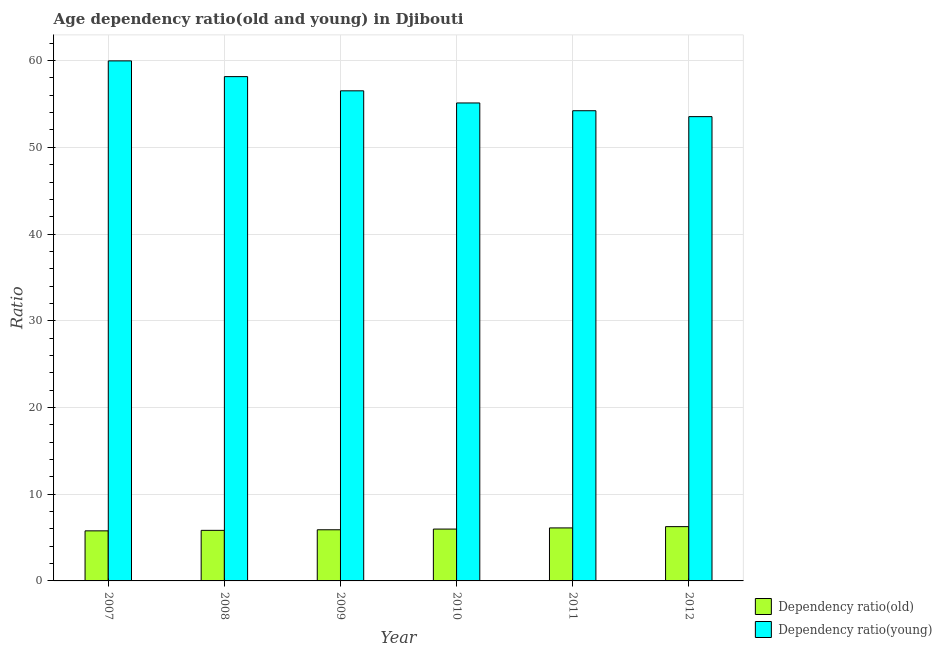How many different coloured bars are there?
Provide a short and direct response. 2. How many bars are there on the 3rd tick from the right?
Your response must be concise. 2. In how many cases, is the number of bars for a given year not equal to the number of legend labels?
Offer a terse response. 0. What is the age dependency ratio(old) in 2007?
Provide a succinct answer. 5.77. Across all years, what is the maximum age dependency ratio(old)?
Offer a terse response. 6.26. Across all years, what is the minimum age dependency ratio(old)?
Your response must be concise. 5.77. What is the total age dependency ratio(old) in the graph?
Your answer should be compact. 35.85. What is the difference between the age dependency ratio(old) in 2007 and that in 2012?
Your answer should be compact. -0.49. What is the difference between the age dependency ratio(young) in 2012 and the age dependency ratio(old) in 2007?
Give a very brief answer. -6.43. What is the average age dependency ratio(young) per year?
Your response must be concise. 56.25. In the year 2011, what is the difference between the age dependency ratio(old) and age dependency ratio(young)?
Offer a very short reply. 0. In how many years, is the age dependency ratio(old) greater than 20?
Ensure brevity in your answer.  0. What is the ratio of the age dependency ratio(young) in 2008 to that in 2010?
Offer a terse response. 1.06. Is the difference between the age dependency ratio(young) in 2010 and 2012 greater than the difference between the age dependency ratio(old) in 2010 and 2012?
Your response must be concise. No. What is the difference between the highest and the second highest age dependency ratio(old)?
Make the answer very short. 0.15. What is the difference between the highest and the lowest age dependency ratio(young)?
Ensure brevity in your answer.  6.43. Is the sum of the age dependency ratio(old) in 2007 and 2010 greater than the maximum age dependency ratio(young) across all years?
Ensure brevity in your answer.  Yes. What does the 1st bar from the left in 2012 represents?
Provide a succinct answer. Dependency ratio(old). What does the 1st bar from the right in 2007 represents?
Offer a very short reply. Dependency ratio(young). How many bars are there?
Keep it short and to the point. 12. How many years are there in the graph?
Ensure brevity in your answer.  6. What is the difference between two consecutive major ticks on the Y-axis?
Offer a very short reply. 10. Are the values on the major ticks of Y-axis written in scientific E-notation?
Give a very brief answer. No. Where does the legend appear in the graph?
Keep it short and to the point. Bottom right. How many legend labels are there?
Ensure brevity in your answer.  2. How are the legend labels stacked?
Your answer should be compact. Vertical. What is the title of the graph?
Your response must be concise. Age dependency ratio(old and young) in Djibouti. What is the label or title of the X-axis?
Ensure brevity in your answer.  Year. What is the label or title of the Y-axis?
Offer a very short reply. Ratio. What is the Ratio in Dependency ratio(old) in 2007?
Offer a very short reply. 5.77. What is the Ratio in Dependency ratio(young) in 2007?
Keep it short and to the point. 59.97. What is the Ratio in Dependency ratio(old) in 2008?
Your answer should be compact. 5.83. What is the Ratio in Dependency ratio(young) in 2008?
Your answer should be compact. 58.15. What is the Ratio in Dependency ratio(old) in 2009?
Offer a terse response. 5.9. What is the Ratio of Dependency ratio(young) in 2009?
Your response must be concise. 56.52. What is the Ratio of Dependency ratio(old) in 2010?
Offer a very short reply. 5.98. What is the Ratio of Dependency ratio(young) in 2010?
Offer a very short reply. 55.12. What is the Ratio of Dependency ratio(old) in 2011?
Offer a very short reply. 6.11. What is the Ratio in Dependency ratio(young) in 2011?
Your response must be concise. 54.22. What is the Ratio in Dependency ratio(old) in 2012?
Offer a terse response. 6.26. What is the Ratio in Dependency ratio(young) in 2012?
Ensure brevity in your answer.  53.54. Across all years, what is the maximum Ratio in Dependency ratio(old)?
Provide a succinct answer. 6.26. Across all years, what is the maximum Ratio of Dependency ratio(young)?
Offer a terse response. 59.97. Across all years, what is the minimum Ratio of Dependency ratio(old)?
Ensure brevity in your answer.  5.77. Across all years, what is the minimum Ratio of Dependency ratio(young)?
Give a very brief answer. 53.54. What is the total Ratio of Dependency ratio(old) in the graph?
Keep it short and to the point. 35.85. What is the total Ratio in Dependency ratio(young) in the graph?
Give a very brief answer. 337.51. What is the difference between the Ratio in Dependency ratio(old) in 2007 and that in 2008?
Keep it short and to the point. -0.06. What is the difference between the Ratio in Dependency ratio(young) in 2007 and that in 2008?
Your answer should be compact. 1.81. What is the difference between the Ratio of Dependency ratio(old) in 2007 and that in 2009?
Your response must be concise. -0.13. What is the difference between the Ratio in Dependency ratio(young) in 2007 and that in 2009?
Keep it short and to the point. 3.45. What is the difference between the Ratio of Dependency ratio(old) in 2007 and that in 2010?
Your response must be concise. -0.21. What is the difference between the Ratio in Dependency ratio(young) in 2007 and that in 2010?
Your answer should be compact. 4.85. What is the difference between the Ratio in Dependency ratio(old) in 2007 and that in 2011?
Your answer should be compact. -0.34. What is the difference between the Ratio in Dependency ratio(young) in 2007 and that in 2011?
Keep it short and to the point. 5.75. What is the difference between the Ratio in Dependency ratio(old) in 2007 and that in 2012?
Give a very brief answer. -0.49. What is the difference between the Ratio of Dependency ratio(young) in 2007 and that in 2012?
Ensure brevity in your answer.  6.43. What is the difference between the Ratio of Dependency ratio(old) in 2008 and that in 2009?
Your answer should be compact. -0.07. What is the difference between the Ratio of Dependency ratio(young) in 2008 and that in 2009?
Your response must be concise. 1.64. What is the difference between the Ratio of Dependency ratio(old) in 2008 and that in 2010?
Provide a short and direct response. -0.15. What is the difference between the Ratio in Dependency ratio(young) in 2008 and that in 2010?
Provide a succinct answer. 3.04. What is the difference between the Ratio in Dependency ratio(old) in 2008 and that in 2011?
Your answer should be compact. -0.28. What is the difference between the Ratio of Dependency ratio(young) in 2008 and that in 2011?
Your answer should be compact. 3.93. What is the difference between the Ratio of Dependency ratio(old) in 2008 and that in 2012?
Offer a very short reply. -0.43. What is the difference between the Ratio of Dependency ratio(young) in 2008 and that in 2012?
Provide a succinct answer. 4.62. What is the difference between the Ratio of Dependency ratio(old) in 2009 and that in 2010?
Your answer should be compact. -0.08. What is the difference between the Ratio of Dependency ratio(young) in 2009 and that in 2010?
Provide a succinct answer. 1.4. What is the difference between the Ratio in Dependency ratio(old) in 2009 and that in 2011?
Your response must be concise. -0.21. What is the difference between the Ratio in Dependency ratio(young) in 2009 and that in 2011?
Give a very brief answer. 2.3. What is the difference between the Ratio in Dependency ratio(old) in 2009 and that in 2012?
Provide a short and direct response. -0.36. What is the difference between the Ratio in Dependency ratio(young) in 2009 and that in 2012?
Your response must be concise. 2.98. What is the difference between the Ratio of Dependency ratio(old) in 2010 and that in 2011?
Your answer should be very brief. -0.13. What is the difference between the Ratio of Dependency ratio(young) in 2010 and that in 2011?
Offer a very short reply. 0.9. What is the difference between the Ratio in Dependency ratio(old) in 2010 and that in 2012?
Offer a terse response. -0.28. What is the difference between the Ratio of Dependency ratio(young) in 2010 and that in 2012?
Keep it short and to the point. 1.58. What is the difference between the Ratio of Dependency ratio(old) in 2011 and that in 2012?
Ensure brevity in your answer.  -0.15. What is the difference between the Ratio of Dependency ratio(young) in 2011 and that in 2012?
Your response must be concise. 0.68. What is the difference between the Ratio of Dependency ratio(old) in 2007 and the Ratio of Dependency ratio(young) in 2008?
Your response must be concise. -52.38. What is the difference between the Ratio of Dependency ratio(old) in 2007 and the Ratio of Dependency ratio(young) in 2009?
Keep it short and to the point. -50.74. What is the difference between the Ratio of Dependency ratio(old) in 2007 and the Ratio of Dependency ratio(young) in 2010?
Your answer should be compact. -49.34. What is the difference between the Ratio of Dependency ratio(old) in 2007 and the Ratio of Dependency ratio(young) in 2011?
Your response must be concise. -48.45. What is the difference between the Ratio in Dependency ratio(old) in 2007 and the Ratio in Dependency ratio(young) in 2012?
Your answer should be compact. -47.77. What is the difference between the Ratio in Dependency ratio(old) in 2008 and the Ratio in Dependency ratio(young) in 2009?
Keep it short and to the point. -50.68. What is the difference between the Ratio of Dependency ratio(old) in 2008 and the Ratio of Dependency ratio(young) in 2010?
Offer a very short reply. -49.29. What is the difference between the Ratio of Dependency ratio(old) in 2008 and the Ratio of Dependency ratio(young) in 2011?
Provide a short and direct response. -48.39. What is the difference between the Ratio of Dependency ratio(old) in 2008 and the Ratio of Dependency ratio(young) in 2012?
Give a very brief answer. -47.71. What is the difference between the Ratio in Dependency ratio(old) in 2009 and the Ratio in Dependency ratio(young) in 2010?
Your answer should be very brief. -49.22. What is the difference between the Ratio of Dependency ratio(old) in 2009 and the Ratio of Dependency ratio(young) in 2011?
Make the answer very short. -48.32. What is the difference between the Ratio of Dependency ratio(old) in 2009 and the Ratio of Dependency ratio(young) in 2012?
Ensure brevity in your answer.  -47.64. What is the difference between the Ratio in Dependency ratio(old) in 2010 and the Ratio in Dependency ratio(young) in 2011?
Your answer should be very brief. -48.24. What is the difference between the Ratio in Dependency ratio(old) in 2010 and the Ratio in Dependency ratio(young) in 2012?
Offer a very short reply. -47.56. What is the difference between the Ratio of Dependency ratio(old) in 2011 and the Ratio of Dependency ratio(young) in 2012?
Ensure brevity in your answer.  -47.43. What is the average Ratio in Dependency ratio(old) per year?
Ensure brevity in your answer.  5.98. What is the average Ratio of Dependency ratio(young) per year?
Your response must be concise. 56.25. In the year 2007, what is the difference between the Ratio of Dependency ratio(old) and Ratio of Dependency ratio(young)?
Make the answer very short. -54.2. In the year 2008, what is the difference between the Ratio in Dependency ratio(old) and Ratio in Dependency ratio(young)?
Provide a short and direct response. -52.32. In the year 2009, what is the difference between the Ratio of Dependency ratio(old) and Ratio of Dependency ratio(young)?
Offer a very short reply. -50.62. In the year 2010, what is the difference between the Ratio of Dependency ratio(old) and Ratio of Dependency ratio(young)?
Your answer should be compact. -49.14. In the year 2011, what is the difference between the Ratio of Dependency ratio(old) and Ratio of Dependency ratio(young)?
Offer a terse response. -48.11. In the year 2012, what is the difference between the Ratio of Dependency ratio(old) and Ratio of Dependency ratio(young)?
Offer a terse response. -47.28. What is the ratio of the Ratio of Dependency ratio(young) in 2007 to that in 2008?
Give a very brief answer. 1.03. What is the ratio of the Ratio of Dependency ratio(old) in 2007 to that in 2009?
Your answer should be compact. 0.98. What is the ratio of the Ratio of Dependency ratio(young) in 2007 to that in 2009?
Your answer should be very brief. 1.06. What is the ratio of the Ratio of Dependency ratio(old) in 2007 to that in 2010?
Offer a very short reply. 0.97. What is the ratio of the Ratio of Dependency ratio(young) in 2007 to that in 2010?
Your answer should be compact. 1.09. What is the ratio of the Ratio in Dependency ratio(old) in 2007 to that in 2011?
Provide a short and direct response. 0.94. What is the ratio of the Ratio of Dependency ratio(young) in 2007 to that in 2011?
Give a very brief answer. 1.11. What is the ratio of the Ratio in Dependency ratio(old) in 2007 to that in 2012?
Your response must be concise. 0.92. What is the ratio of the Ratio of Dependency ratio(young) in 2007 to that in 2012?
Ensure brevity in your answer.  1.12. What is the ratio of the Ratio in Dependency ratio(old) in 2008 to that in 2010?
Keep it short and to the point. 0.98. What is the ratio of the Ratio of Dependency ratio(young) in 2008 to that in 2010?
Provide a succinct answer. 1.06. What is the ratio of the Ratio in Dependency ratio(old) in 2008 to that in 2011?
Offer a very short reply. 0.95. What is the ratio of the Ratio in Dependency ratio(young) in 2008 to that in 2011?
Give a very brief answer. 1.07. What is the ratio of the Ratio of Dependency ratio(old) in 2008 to that in 2012?
Your response must be concise. 0.93. What is the ratio of the Ratio in Dependency ratio(young) in 2008 to that in 2012?
Provide a short and direct response. 1.09. What is the ratio of the Ratio of Dependency ratio(old) in 2009 to that in 2010?
Your answer should be very brief. 0.99. What is the ratio of the Ratio in Dependency ratio(young) in 2009 to that in 2010?
Provide a short and direct response. 1.03. What is the ratio of the Ratio of Dependency ratio(old) in 2009 to that in 2011?
Make the answer very short. 0.96. What is the ratio of the Ratio in Dependency ratio(young) in 2009 to that in 2011?
Ensure brevity in your answer.  1.04. What is the ratio of the Ratio of Dependency ratio(old) in 2009 to that in 2012?
Your response must be concise. 0.94. What is the ratio of the Ratio in Dependency ratio(young) in 2009 to that in 2012?
Ensure brevity in your answer.  1.06. What is the ratio of the Ratio in Dependency ratio(old) in 2010 to that in 2011?
Keep it short and to the point. 0.98. What is the ratio of the Ratio of Dependency ratio(young) in 2010 to that in 2011?
Ensure brevity in your answer.  1.02. What is the ratio of the Ratio of Dependency ratio(old) in 2010 to that in 2012?
Your answer should be compact. 0.95. What is the ratio of the Ratio of Dependency ratio(young) in 2010 to that in 2012?
Keep it short and to the point. 1.03. What is the ratio of the Ratio of Dependency ratio(old) in 2011 to that in 2012?
Give a very brief answer. 0.98. What is the ratio of the Ratio in Dependency ratio(young) in 2011 to that in 2012?
Provide a succinct answer. 1.01. What is the difference between the highest and the second highest Ratio of Dependency ratio(old)?
Your response must be concise. 0.15. What is the difference between the highest and the second highest Ratio of Dependency ratio(young)?
Offer a terse response. 1.81. What is the difference between the highest and the lowest Ratio of Dependency ratio(old)?
Offer a very short reply. 0.49. What is the difference between the highest and the lowest Ratio of Dependency ratio(young)?
Ensure brevity in your answer.  6.43. 